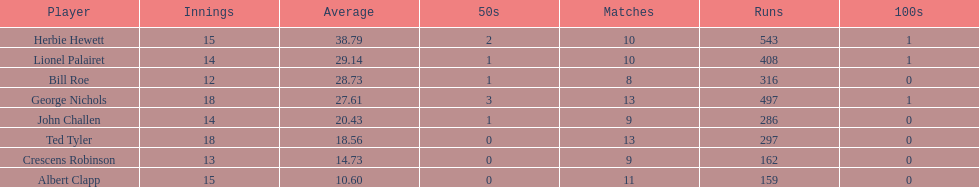Name a player whose average was above 25. Herbie Hewett. 